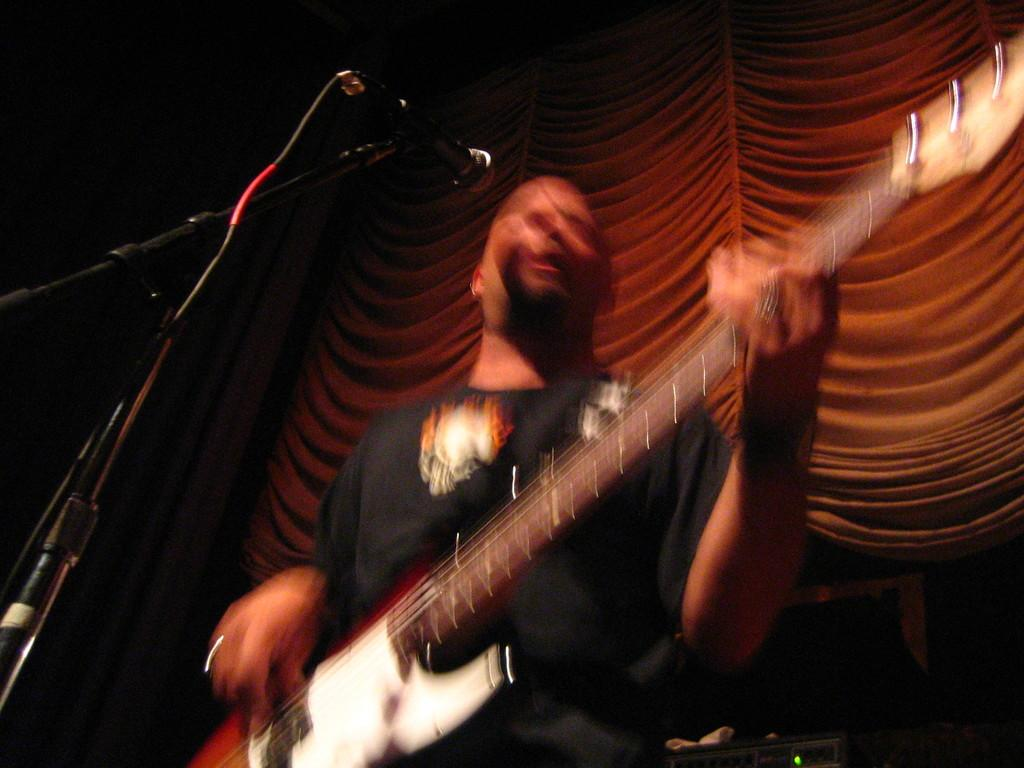What is the main subject of the image? There is a person in the image. What is the person holding in the image? The person is holding a guitar. What object is in front of the person that might be used for amplifying their voice? There is a microphone with a stand in front of the person. What type of mitten is the person wearing on their left hand in the image? There is no mitten visible in the image; the person is holding a guitar. What type of berry is the person eating in the image? There is no berry present in the image; the person is holding a guitar. 